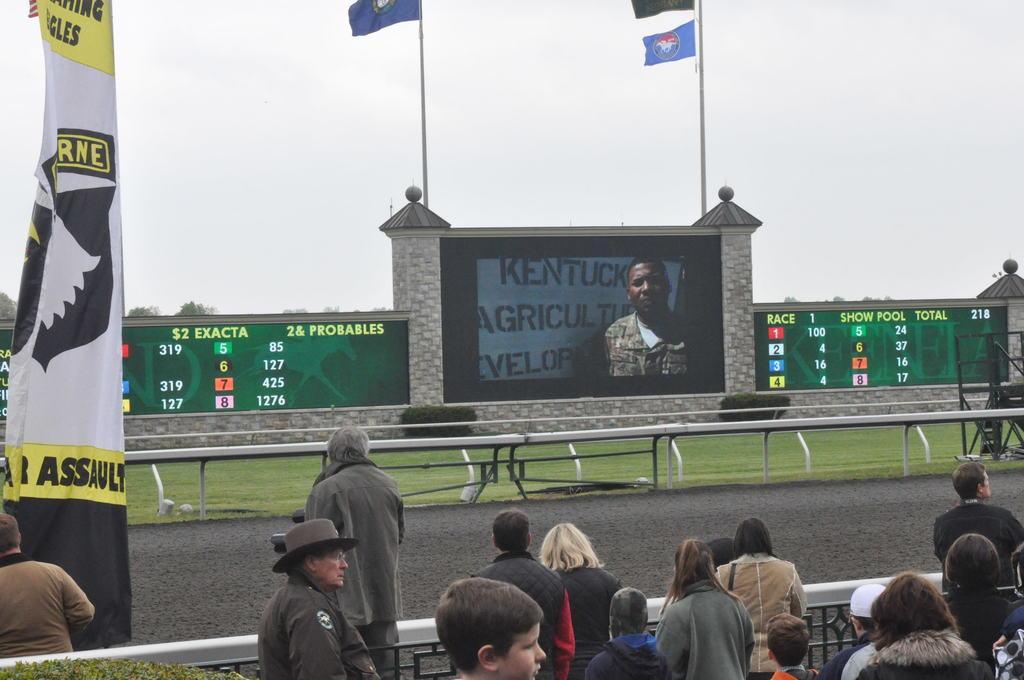How would you summarize this image in a sentence or two? In the picture there is some race is going to take place, the spectators were standing behind the fence, on the left side there is a banner. There is a screen and on the either side of the screen there are few flags and score boards. 